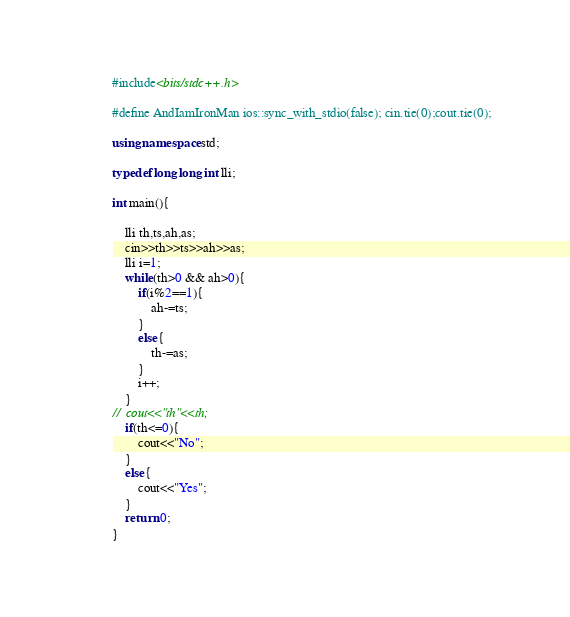<code> <loc_0><loc_0><loc_500><loc_500><_C++_>#include<bits/stdc++.h>

#define AndIamIronMan ios::sync_with_stdio(false); cin.tie(0);cout.tie(0); 
 
using namespace std;
 
typedef long long int lli; 
 
int main(){
    
	lli th,ts,ah,as;
	cin>>th>>ts>>ah>>as;
	lli i=1;
	while(th>0 && ah>0){
		if(i%2==1){
			ah-=ts;
		}
		else{
			th-=as;
		}
		i++;
	}
//	cout<<"th"<<th;
	if(th<=0){
		cout<<"No";
	}
	else{
		cout<<"Yes";
	}
    return 0;
}</code> 